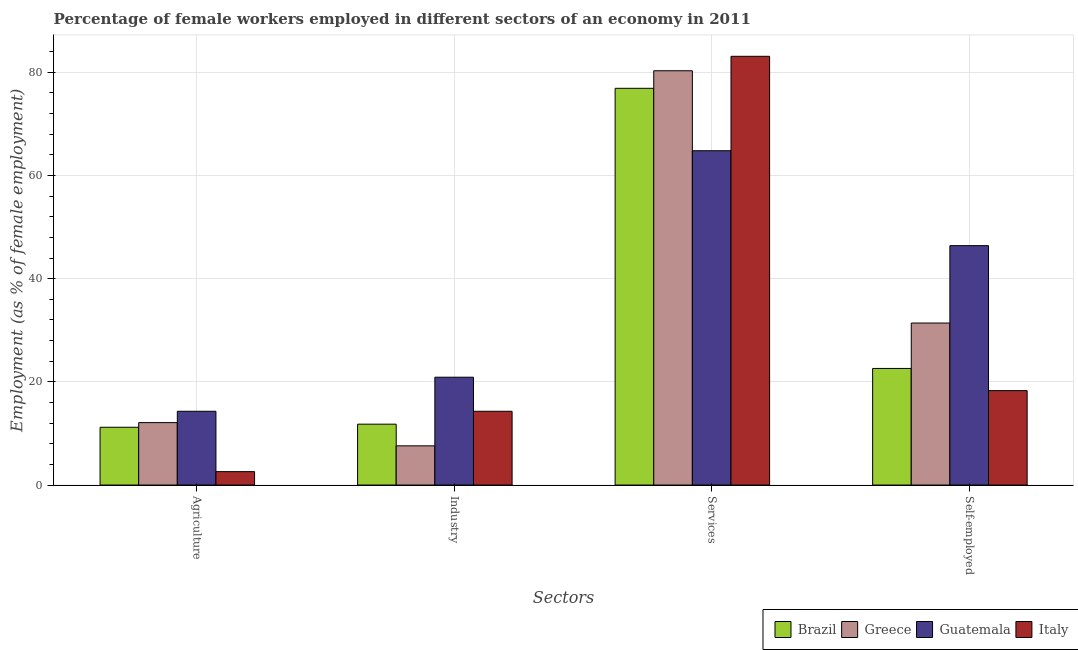How many different coloured bars are there?
Make the answer very short. 4. Are the number of bars per tick equal to the number of legend labels?
Ensure brevity in your answer.  Yes. Are the number of bars on each tick of the X-axis equal?
Give a very brief answer. Yes. How many bars are there on the 1st tick from the right?
Provide a short and direct response. 4. What is the label of the 2nd group of bars from the left?
Make the answer very short. Industry. What is the percentage of female workers in services in Italy?
Give a very brief answer. 83.1. Across all countries, what is the maximum percentage of female workers in services?
Your answer should be compact. 83.1. Across all countries, what is the minimum percentage of female workers in agriculture?
Ensure brevity in your answer.  2.6. In which country was the percentage of female workers in industry maximum?
Your response must be concise. Guatemala. In which country was the percentage of female workers in agriculture minimum?
Offer a very short reply. Italy. What is the total percentage of self employed female workers in the graph?
Your answer should be compact. 118.7. What is the difference between the percentage of female workers in industry in Guatemala and that in Italy?
Give a very brief answer. 6.6. What is the difference between the percentage of female workers in services in Guatemala and the percentage of female workers in industry in Brazil?
Your response must be concise. 53. What is the average percentage of female workers in agriculture per country?
Your answer should be compact. 10.05. What is the difference between the percentage of female workers in services and percentage of female workers in industry in Italy?
Your response must be concise. 68.8. What is the ratio of the percentage of female workers in agriculture in Guatemala to that in Italy?
Your answer should be compact. 5.5. Is the percentage of self employed female workers in Italy less than that in Brazil?
Ensure brevity in your answer.  Yes. What is the difference between the highest and the second highest percentage of female workers in agriculture?
Your answer should be very brief. 2.2. What is the difference between the highest and the lowest percentage of self employed female workers?
Provide a succinct answer. 28.1. Is it the case that in every country, the sum of the percentage of female workers in industry and percentage of female workers in services is greater than the sum of percentage of self employed female workers and percentage of female workers in agriculture?
Your answer should be very brief. Yes. What does the 4th bar from the left in Agriculture represents?
Make the answer very short. Italy. What does the 4th bar from the right in Services represents?
Give a very brief answer. Brazil. Is it the case that in every country, the sum of the percentage of female workers in agriculture and percentage of female workers in industry is greater than the percentage of female workers in services?
Give a very brief answer. No. Are all the bars in the graph horizontal?
Keep it short and to the point. No. Are the values on the major ticks of Y-axis written in scientific E-notation?
Offer a very short reply. No. Does the graph contain grids?
Make the answer very short. Yes. How are the legend labels stacked?
Offer a terse response. Horizontal. What is the title of the graph?
Provide a short and direct response. Percentage of female workers employed in different sectors of an economy in 2011. Does "Haiti" appear as one of the legend labels in the graph?
Your answer should be compact. No. What is the label or title of the X-axis?
Provide a succinct answer. Sectors. What is the label or title of the Y-axis?
Offer a terse response. Employment (as % of female employment). What is the Employment (as % of female employment) of Brazil in Agriculture?
Provide a succinct answer. 11.2. What is the Employment (as % of female employment) of Greece in Agriculture?
Your answer should be compact. 12.1. What is the Employment (as % of female employment) in Guatemala in Agriculture?
Provide a short and direct response. 14.3. What is the Employment (as % of female employment) in Italy in Agriculture?
Provide a succinct answer. 2.6. What is the Employment (as % of female employment) in Brazil in Industry?
Provide a short and direct response. 11.8. What is the Employment (as % of female employment) in Greece in Industry?
Offer a terse response. 7.6. What is the Employment (as % of female employment) of Guatemala in Industry?
Give a very brief answer. 20.9. What is the Employment (as % of female employment) of Italy in Industry?
Provide a short and direct response. 14.3. What is the Employment (as % of female employment) of Brazil in Services?
Provide a short and direct response. 76.9. What is the Employment (as % of female employment) of Greece in Services?
Your response must be concise. 80.3. What is the Employment (as % of female employment) of Guatemala in Services?
Give a very brief answer. 64.8. What is the Employment (as % of female employment) in Italy in Services?
Keep it short and to the point. 83.1. What is the Employment (as % of female employment) of Brazil in Self-employed?
Your response must be concise. 22.6. What is the Employment (as % of female employment) of Greece in Self-employed?
Offer a very short reply. 31.4. What is the Employment (as % of female employment) of Guatemala in Self-employed?
Give a very brief answer. 46.4. What is the Employment (as % of female employment) of Italy in Self-employed?
Offer a terse response. 18.3. Across all Sectors, what is the maximum Employment (as % of female employment) of Brazil?
Give a very brief answer. 76.9. Across all Sectors, what is the maximum Employment (as % of female employment) of Greece?
Ensure brevity in your answer.  80.3. Across all Sectors, what is the maximum Employment (as % of female employment) in Guatemala?
Your answer should be very brief. 64.8. Across all Sectors, what is the maximum Employment (as % of female employment) in Italy?
Give a very brief answer. 83.1. Across all Sectors, what is the minimum Employment (as % of female employment) in Brazil?
Keep it short and to the point. 11.2. Across all Sectors, what is the minimum Employment (as % of female employment) of Greece?
Your response must be concise. 7.6. Across all Sectors, what is the minimum Employment (as % of female employment) in Guatemala?
Keep it short and to the point. 14.3. Across all Sectors, what is the minimum Employment (as % of female employment) in Italy?
Ensure brevity in your answer.  2.6. What is the total Employment (as % of female employment) of Brazil in the graph?
Offer a very short reply. 122.5. What is the total Employment (as % of female employment) in Greece in the graph?
Your response must be concise. 131.4. What is the total Employment (as % of female employment) of Guatemala in the graph?
Provide a succinct answer. 146.4. What is the total Employment (as % of female employment) of Italy in the graph?
Ensure brevity in your answer.  118.3. What is the difference between the Employment (as % of female employment) in Brazil in Agriculture and that in Industry?
Give a very brief answer. -0.6. What is the difference between the Employment (as % of female employment) of Greece in Agriculture and that in Industry?
Your answer should be compact. 4.5. What is the difference between the Employment (as % of female employment) in Guatemala in Agriculture and that in Industry?
Your answer should be compact. -6.6. What is the difference between the Employment (as % of female employment) of Italy in Agriculture and that in Industry?
Give a very brief answer. -11.7. What is the difference between the Employment (as % of female employment) in Brazil in Agriculture and that in Services?
Make the answer very short. -65.7. What is the difference between the Employment (as % of female employment) of Greece in Agriculture and that in Services?
Give a very brief answer. -68.2. What is the difference between the Employment (as % of female employment) of Guatemala in Agriculture and that in Services?
Your response must be concise. -50.5. What is the difference between the Employment (as % of female employment) in Italy in Agriculture and that in Services?
Give a very brief answer. -80.5. What is the difference between the Employment (as % of female employment) of Brazil in Agriculture and that in Self-employed?
Your answer should be very brief. -11.4. What is the difference between the Employment (as % of female employment) of Greece in Agriculture and that in Self-employed?
Your answer should be very brief. -19.3. What is the difference between the Employment (as % of female employment) in Guatemala in Agriculture and that in Self-employed?
Offer a terse response. -32.1. What is the difference between the Employment (as % of female employment) of Italy in Agriculture and that in Self-employed?
Give a very brief answer. -15.7. What is the difference between the Employment (as % of female employment) of Brazil in Industry and that in Services?
Provide a succinct answer. -65.1. What is the difference between the Employment (as % of female employment) in Greece in Industry and that in Services?
Offer a terse response. -72.7. What is the difference between the Employment (as % of female employment) of Guatemala in Industry and that in Services?
Make the answer very short. -43.9. What is the difference between the Employment (as % of female employment) in Italy in Industry and that in Services?
Provide a succinct answer. -68.8. What is the difference between the Employment (as % of female employment) of Brazil in Industry and that in Self-employed?
Offer a terse response. -10.8. What is the difference between the Employment (as % of female employment) in Greece in Industry and that in Self-employed?
Offer a terse response. -23.8. What is the difference between the Employment (as % of female employment) of Guatemala in Industry and that in Self-employed?
Your response must be concise. -25.5. What is the difference between the Employment (as % of female employment) of Italy in Industry and that in Self-employed?
Your answer should be compact. -4. What is the difference between the Employment (as % of female employment) of Brazil in Services and that in Self-employed?
Offer a very short reply. 54.3. What is the difference between the Employment (as % of female employment) in Greece in Services and that in Self-employed?
Offer a very short reply. 48.9. What is the difference between the Employment (as % of female employment) in Italy in Services and that in Self-employed?
Offer a very short reply. 64.8. What is the difference between the Employment (as % of female employment) of Brazil in Agriculture and the Employment (as % of female employment) of Greece in Industry?
Keep it short and to the point. 3.6. What is the difference between the Employment (as % of female employment) in Brazil in Agriculture and the Employment (as % of female employment) in Guatemala in Industry?
Provide a short and direct response. -9.7. What is the difference between the Employment (as % of female employment) in Greece in Agriculture and the Employment (as % of female employment) in Guatemala in Industry?
Give a very brief answer. -8.8. What is the difference between the Employment (as % of female employment) of Brazil in Agriculture and the Employment (as % of female employment) of Greece in Services?
Your response must be concise. -69.1. What is the difference between the Employment (as % of female employment) in Brazil in Agriculture and the Employment (as % of female employment) in Guatemala in Services?
Your response must be concise. -53.6. What is the difference between the Employment (as % of female employment) of Brazil in Agriculture and the Employment (as % of female employment) of Italy in Services?
Offer a terse response. -71.9. What is the difference between the Employment (as % of female employment) of Greece in Agriculture and the Employment (as % of female employment) of Guatemala in Services?
Offer a very short reply. -52.7. What is the difference between the Employment (as % of female employment) of Greece in Agriculture and the Employment (as % of female employment) of Italy in Services?
Keep it short and to the point. -71. What is the difference between the Employment (as % of female employment) of Guatemala in Agriculture and the Employment (as % of female employment) of Italy in Services?
Ensure brevity in your answer.  -68.8. What is the difference between the Employment (as % of female employment) of Brazil in Agriculture and the Employment (as % of female employment) of Greece in Self-employed?
Your answer should be compact. -20.2. What is the difference between the Employment (as % of female employment) of Brazil in Agriculture and the Employment (as % of female employment) of Guatemala in Self-employed?
Offer a terse response. -35.2. What is the difference between the Employment (as % of female employment) in Brazil in Agriculture and the Employment (as % of female employment) in Italy in Self-employed?
Keep it short and to the point. -7.1. What is the difference between the Employment (as % of female employment) of Greece in Agriculture and the Employment (as % of female employment) of Guatemala in Self-employed?
Your answer should be very brief. -34.3. What is the difference between the Employment (as % of female employment) in Brazil in Industry and the Employment (as % of female employment) in Greece in Services?
Provide a short and direct response. -68.5. What is the difference between the Employment (as % of female employment) in Brazil in Industry and the Employment (as % of female employment) in Guatemala in Services?
Ensure brevity in your answer.  -53. What is the difference between the Employment (as % of female employment) of Brazil in Industry and the Employment (as % of female employment) of Italy in Services?
Offer a terse response. -71.3. What is the difference between the Employment (as % of female employment) of Greece in Industry and the Employment (as % of female employment) of Guatemala in Services?
Your answer should be compact. -57.2. What is the difference between the Employment (as % of female employment) in Greece in Industry and the Employment (as % of female employment) in Italy in Services?
Provide a short and direct response. -75.5. What is the difference between the Employment (as % of female employment) of Guatemala in Industry and the Employment (as % of female employment) of Italy in Services?
Make the answer very short. -62.2. What is the difference between the Employment (as % of female employment) in Brazil in Industry and the Employment (as % of female employment) in Greece in Self-employed?
Provide a short and direct response. -19.6. What is the difference between the Employment (as % of female employment) in Brazil in Industry and the Employment (as % of female employment) in Guatemala in Self-employed?
Your answer should be very brief. -34.6. What is the difference between the Employment (as % of female employment) of Brazil in Industry and the Employment (as % of female employment) of Italy in Self-employed?
Ensure brevity in your answer.  -6.5. What is the difference between the Employment (as % of female employment) in Greece in Industry and the Employment (as % of female employment) in Guatemala in Self-employed?
Keep it short and to the point. -38.8. What is the difference between the Employment (as % of female employment) of Greece in Industry and the Employment (as % of female employment) of Italy in Self-employed?
Your response must be concise. -10.7. What is the difference between the Employment (as % of female employment) in Guatemala in Industry and the Employment (as % of female employment) in Italy in Self-employed?
Provide a short and direct response. 2.6. What is the difference between the Employment (as % of female employment) in Brazil in Services and the Employment (as % of female employment) in Greece in Self-employed?
Provide a succinct answer. 45.5. What is the difference between the Employment (as % of female employment) in Brazil in Services and the Employment (as % of female employment) in Guatemala in Self-employed?
Make the answer very short. 30.5. What is the difference between the Employment (as % of female employment) of Brazil in Services and the Employment (as % of female employment) of Italy in Self-employed?
Make the answer very short. 58.6. What is the difference between the Employment (as % of female employment) of Greece in Services and the Employment (as % of female employment) of Guatemala in Self-employed?
Your answer should be very brief. 33.9. What is the difference between the Employment (as % of female employment) in Guatemala in Services and the Employment (as % of female employment) in Italy in Self-employed?
Ensure brevity in your answer.  46.5. What is the average Employment (as % of female employment) in Brazil per Sectors?
Provide a short and direct response. 30.62. What is the average Employment (as % of female employment) of Greece per Sectors?
Offer a terse response. 32.85. What is the average Employment (as % of female employment) of Guatemala per Sectors?
Your response must be concise. 36.6. What is the average Employment (as % of female employment) in Italy per Sectors?
Your response must be concise. 29.57. What is the difference between the Employment (as % of female employment) of Brazil and Employment (as % of female employment) of Greece in Agriculture?
Offer a very short reply. -0.9. What is the difference between the Employment (as % of female employment) in Brazil and Employment (as % of female employment) in Guatemala in Agriculture?
Ensure brevity in your answer.  -3.1. What is the difference between the Employment (as % of female employment) of Brazil and Employment (as % of female employment) of Italy in Agriculture?
Your answer should be compact. 8.6. What is the difference between the Employment (as % of female employment) in Brazil and Employment (as % of female employment) in Guatemala in Industry?
Keep it short and to the point. -9.1. What is the difference between the Employment (as % of female employment) of Greece and Employment (as % of female employment) of Guatemala in Industry?
Offer a terse response. -13.3. What is the difference between the Employment (as % of female employment) in Guatemala and Employment (as % of female employment) in Italy in Industry?
Provide a short and direct response. 6.6. What is the difference between the Employment (as % of female employment) in Brazil and Employment (as % of female employment) in Greece in Services?
Keep it short and to the point. -3.4. What is the difference between the Employment (as % of female employment) of Brazil and Employment (as % of female employment) of Guatemala in Services?
Keep it short and to the point. 12.1. What is the difference between the Employment (as % of female employment) of Guatemala and Employment (as % of female employment) of Italy in Services?
Your answer should be very brief. -18.3. What is the difference between the Employment (as % of female employment) of Brazil and Employment (as % of female employment) of Greece in Self-employed?
Keep it short and to the point. -8.8. What is the difference between the Employment (as % of female employment) of Brazil and Employment (as % of female employment) of Guatemala in Self-employed?
Offer a very short reply. -23.8. What is the difference between the Employment (as % of female employment) of Guatemala and Employment (as % of female employment) of Italy in Self-employed?
Ensure brevity in your answer.  28.1. What is the ratio of the Employment (as % of female employment) of Brazil in Agriculture to that in Industry?
Make the answer very short. 0.95. What is the ratio of the Employment (as % of female employment) of Greece in Agriculture to that in Industry?
Your response must be concise. 1.59. What is the ratio of the Employment (as % of female employment) in Guatemala in Agriculture to that in Industry?
Provide a succinct answer. 0.68. What is the ratio of the Employment (as % of female employment) of Italy in Agriculture to that in Industry?
Provide a short and direct response. 0.18. What is the ratio of the Employment (as % of female employment) in Brazil in Agriculture to that in Services?
Your answer should be very brief. 0.15. What is the ratio of the Employment (as % of female employment) in Greece in Agriculture to that in Services?
Offer a terse response. 0.15. What is the ratio of the Employment (as % of female employment) in Guatemala in Agriculture to that in Services?
Offer a terse response. 0.22. What is the ratio of the Employment (as % of female employment) in Italy in Agriculture to that in Services?
Offer a very short reply. 0.03. What is the ratio of the Employment (as % of female employment) in Brazil in Agriculture to that in Self-employed?
Provide a short and direct response. 0.5. What is the ratio of the Employment (as % of female employment) in Greece in Agriculture to that in Self-employed?
Offer a very short reply. 0.39. What is the ratio of the Employment (as % of female employment) in Guatemala in Agriculture to that in Self-employed?
Ensure brevity in your answer.  0.31. What is the ratio of the Employment (as % of female employment) in Italy in Agriculture to that in Self-employed?
Offer a very short reply. 0.14. What is the ratio of the Employment (as % of female employment) of Brazil in Industry to that in Services?
Keep it short and to the point. 0.15. What is the ratio of the Employment (as % of female employment) of Greece in Industry to that in Services?
Your answer should be very brief. 0.09. What is the ratio of the Employment (as % of female employment) in Guatemala in Industry to that in Services?
Ensure brevity in your answer.  0.32. What is the ratio of the Employment (as % of female employment) of Italy in Industry to that in Services?
Make the answer very short. 0.17. What is the ratio of the Employment (as % of female employment) of Brazil in Industry to that in Self-employed?
Ensure brevity in your answer.  0.52. What is the ratio of the Employment (as % of female employment) of Greece in Industry to that in Self-employed?
Provide a succinct answer. 0.24. What is the ratio of the Employment (as % of female employment) of Guatemala in Industry to that in Self-employed?
Give a very brief answer. 0.45. What is the ratio of the Employment (as % of female employment) in Italy in Industry to that in Self-employed?
Provide a succinct answer. 0.78. What is the ratio of the Employment (as % of female employment) in Brazil in Services to that in Self-employed?
Your response must be concise. 3.4. What is the ratio of the Employment (as % of female employment) of Greece in Services to that in Self-employed?
Your answer should be compact. 2.56. What is the ratio of the Employment (as % of female employment) in Guatemala in Services to that in Self-employed?
Your answer should be very brief. 1.4. What is the ratio of the Employment (as % of female employment) of Italy in Services to that in Self-employed?
Keep it short and to the point. 4.54. What is the difference between the highest and the second highest Employment (as % of female employment) of Brazil?
Ensure brevity in your answer.  54.3. What is the difference between the highest and the second highest Employment (as % of female employment) of Greece?
Your answer should be very brief. 48.9. What is the difference between the highest and the second highest Employment (as % of female employment) of Guatemala?
Your answer should be compact. 18.4. What is the difference between the highest and the second highest Employment (as % of female employment) in Italy?
Your response must be concise. 64.8. What is the difference between the highest and the lowest Employment (as % of female employment) of Brazil?
Your answer should be compact. 65.7. What is the difference between the highest and the lowest Employment (as % of female employment) in Greece?
Give a very brief answer. 72.7. What is the difference between the highest and the lowest Employment (as % of female employment) of Guatemala?
Your answer should be very brief. 50.5. What is the difference between the highest and the lowest Employment (as % of female employment) of Italy?
Offer a terse response. 80.5. 